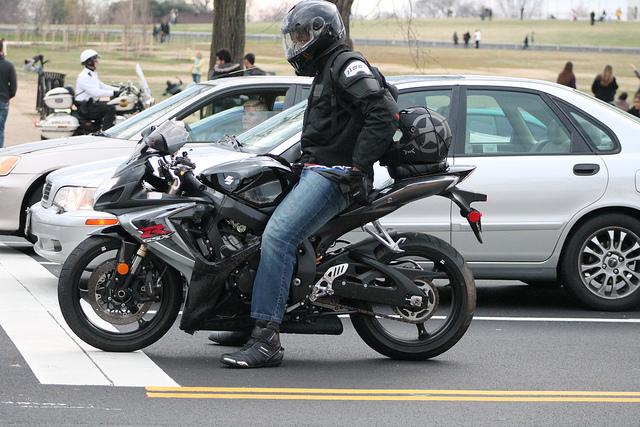Is the motorcycle rider wearing boots?
Concise answer only. No. Is one of the cars a BMW?
Write a very short answer. No. Is this a policeman?
Write a very short answer. No. What color is the biker's helmet?
Be succinct. Black. What is the front tire on?
Answer briefly. White line. How many bikes?
Write a very short answer. 2. Who is riding the motorcycle?
Write a very short answer. Man. 